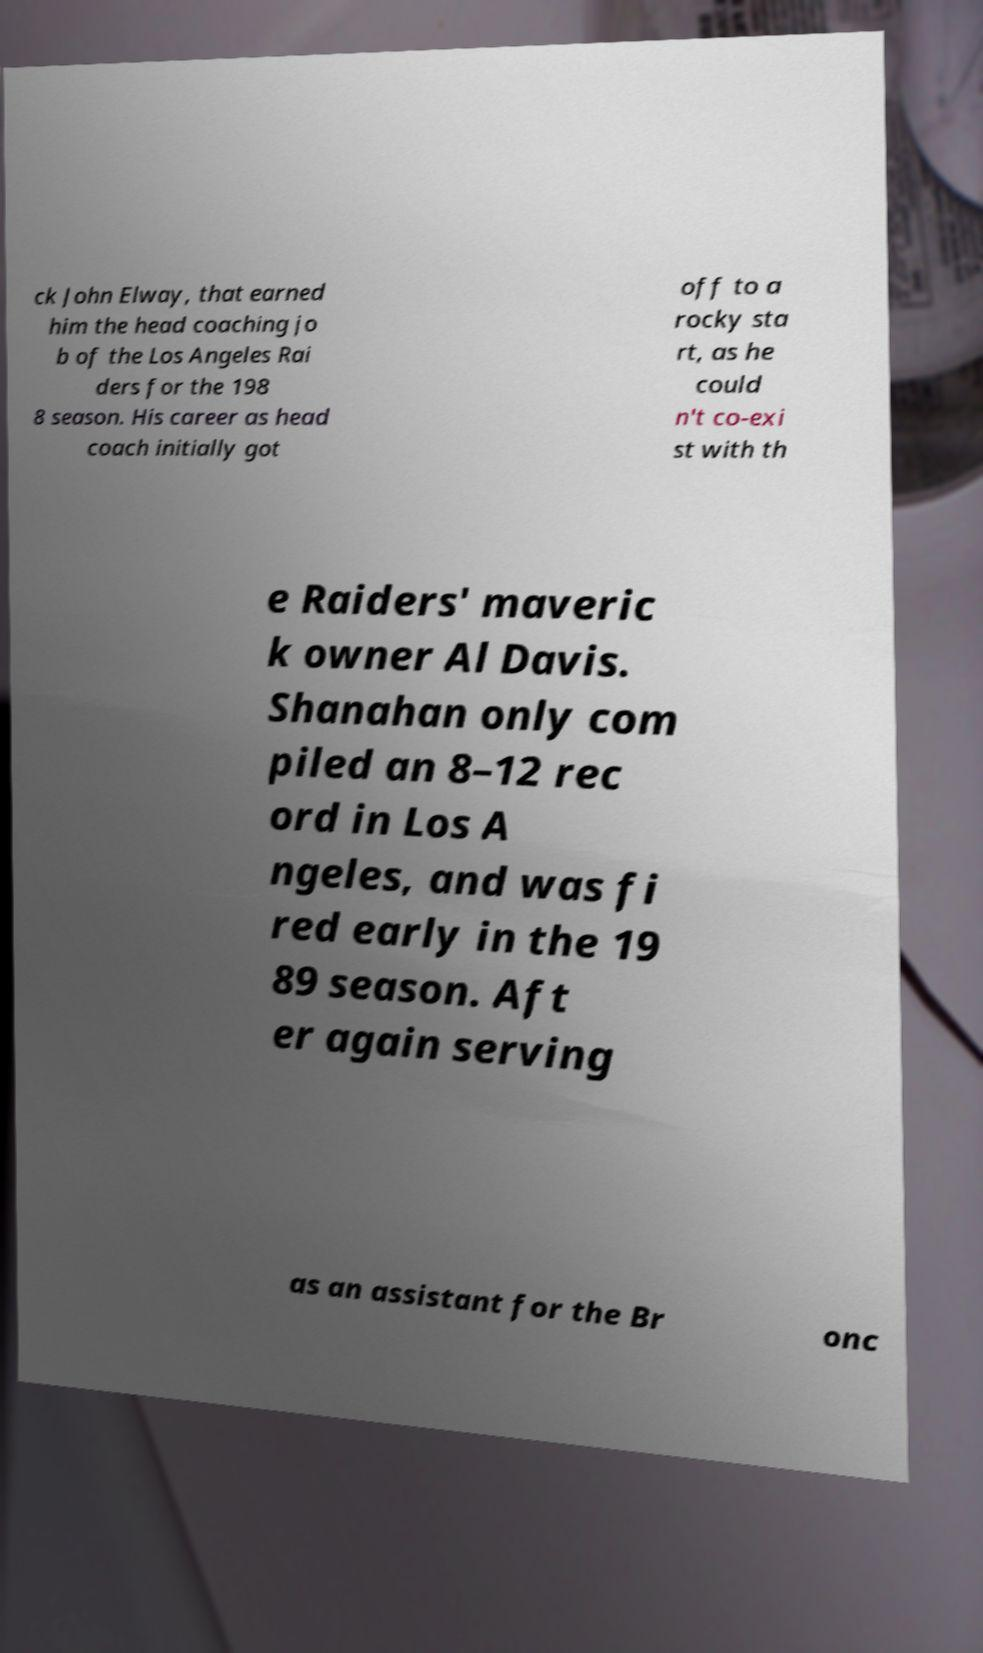Can you read and provide the text displayed in the image?This photo seems to have some interesting text. Can you extract and type it out for me? ck John Elway, that earned him the head coaching jo b of the Los Angeles Rai ders for the 198 8 season. His career as head coach initially got off to a rocky sta rt, as he could n't co-exi st with th e Raiders' maveric k owner Al Davis. Shanahan only com piled an 8–12 rec ord in Los A ngeles, and was fi red early in the 19 89 season. Aft er again serving as an assistant for the Br onc 